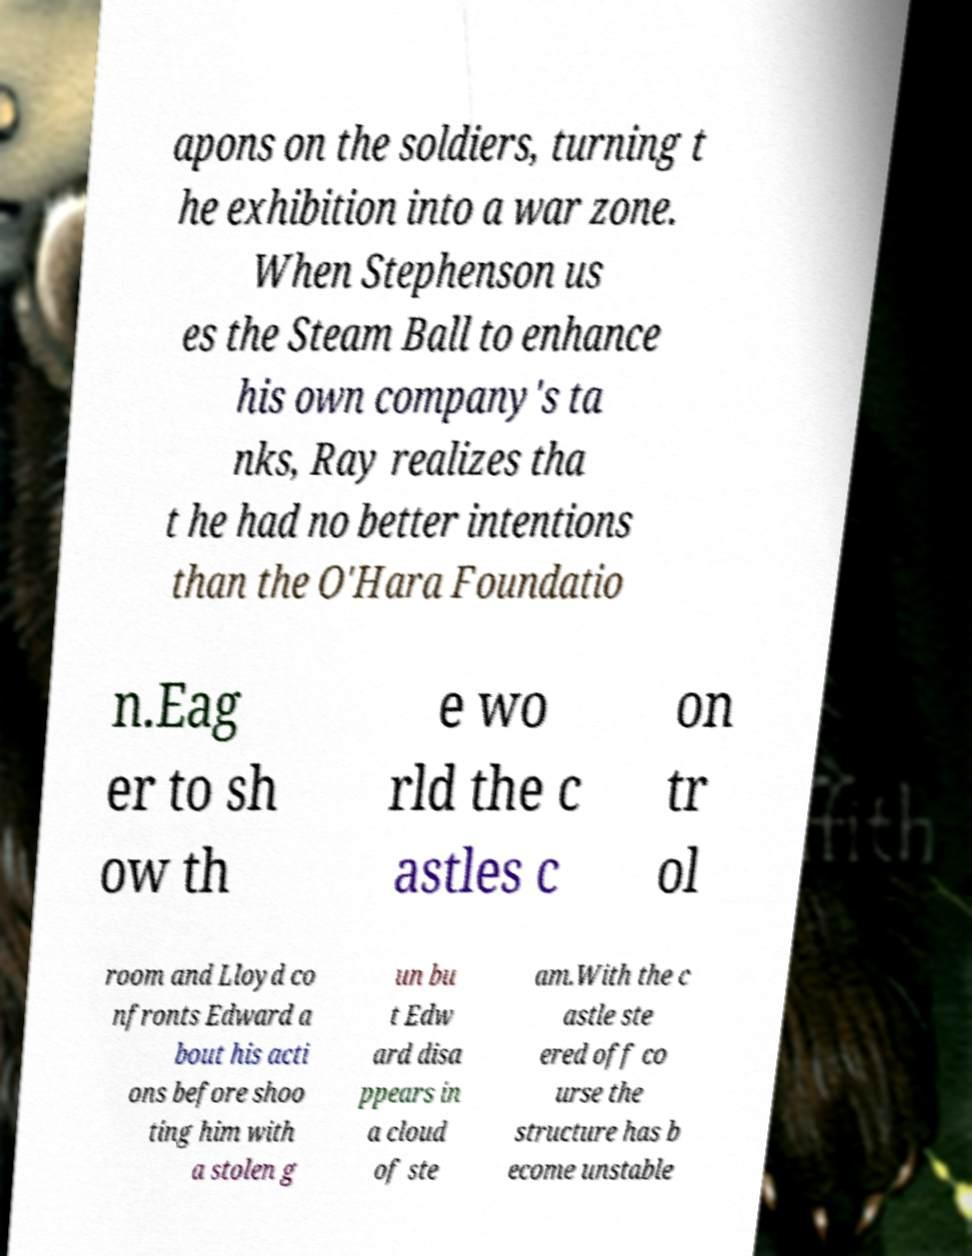There's text embedded in this image that I need extracted. Can you transcribe it verbatim? apons on the soldiers, turning t he exhibition into a war zone. When Stephenson us es the Steam Ball to enhance his own company's ta nks, Ray realizes tha t he had no better intentions than the O'Hara Foundatio n.Eag er to sh ow th e wo rld the c astles c on tr ol room and Lloyd co nfronts Edward a bout his acti ons before shoo ting him with a stolen g un bu t Edw ard disa ppears in a cloud of ste am.With the c astle ste ered off co urse the structure has b ecome unstable 